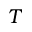<formula> <loc_0><loc_0><loc_500><loc_500>T</formula> 